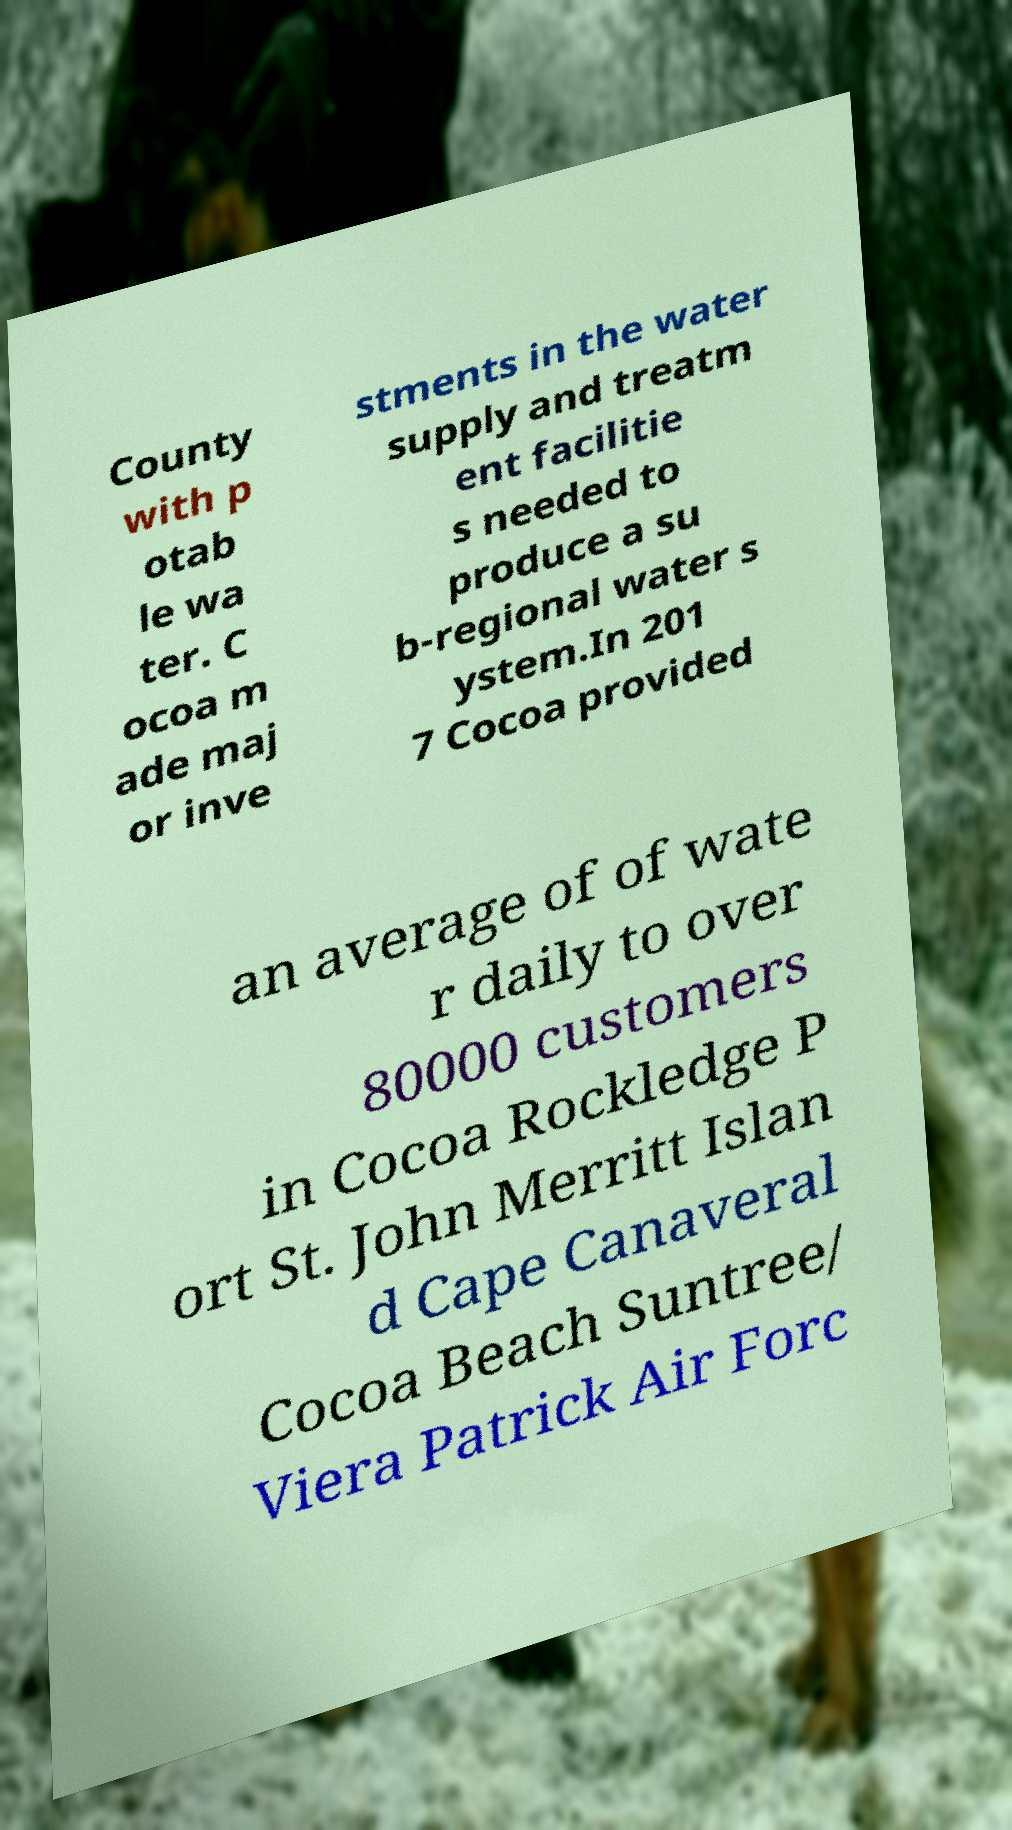Could you assist in decoding the text presented in this image and type it out clearly? County with p otab le wa ter. C ocoa m ade maj or inve stments in the water supply and treatm ent facilitie s needed to produce a su b-regional water s ystem.In 201 7 Cocoa provided an average of of wate r daily to over 80000 customers in Cocoa Rockledge P ort St. John Merritt Islan d Cape Canaveral Cocoa Beach Suntree/ Viera Patrick Air Forc 